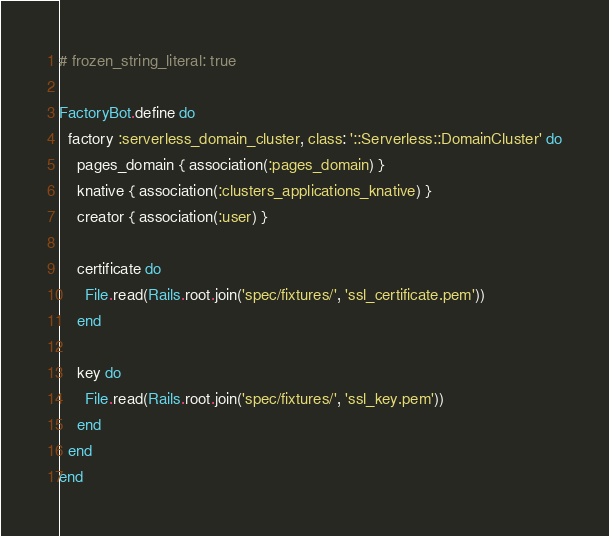<code> <loc_0><loc_0><loc_500><loc_500><_Ruby_># frozen_string_literal: true

FactoryBot.define do
  factory :serverless_domain_cluster, class: '::Serverless::DomainCluster' do
    pages_domain { association(:pages_domain) }
    knative { association(:clusters_applications_knative) }
    creator { association(:user) }

    certificate do
      File.read(Rails.root.join('spec/fixtures/', 'ssl_certificate.pem'))
    end

    key do
      File.read(Rails.root.join('spec/fixtures/', 'ssl_key.pem'))
    end
  end
end
</code> 